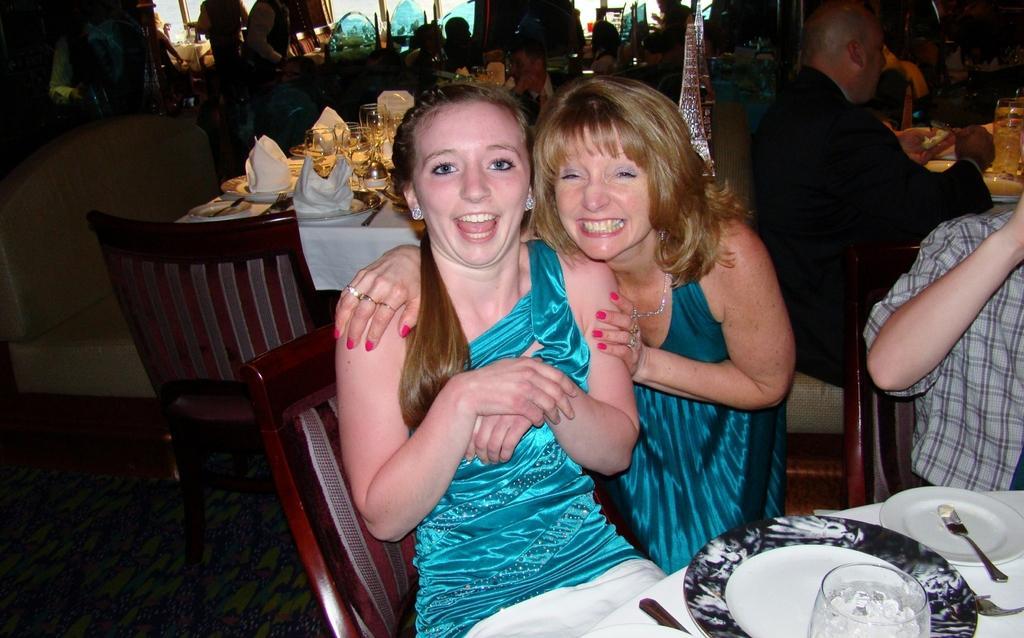Can you describe this image briefly? In this image I can see the group of people sitting in front of the table. On the table there is a glass,plate and the spoons. 